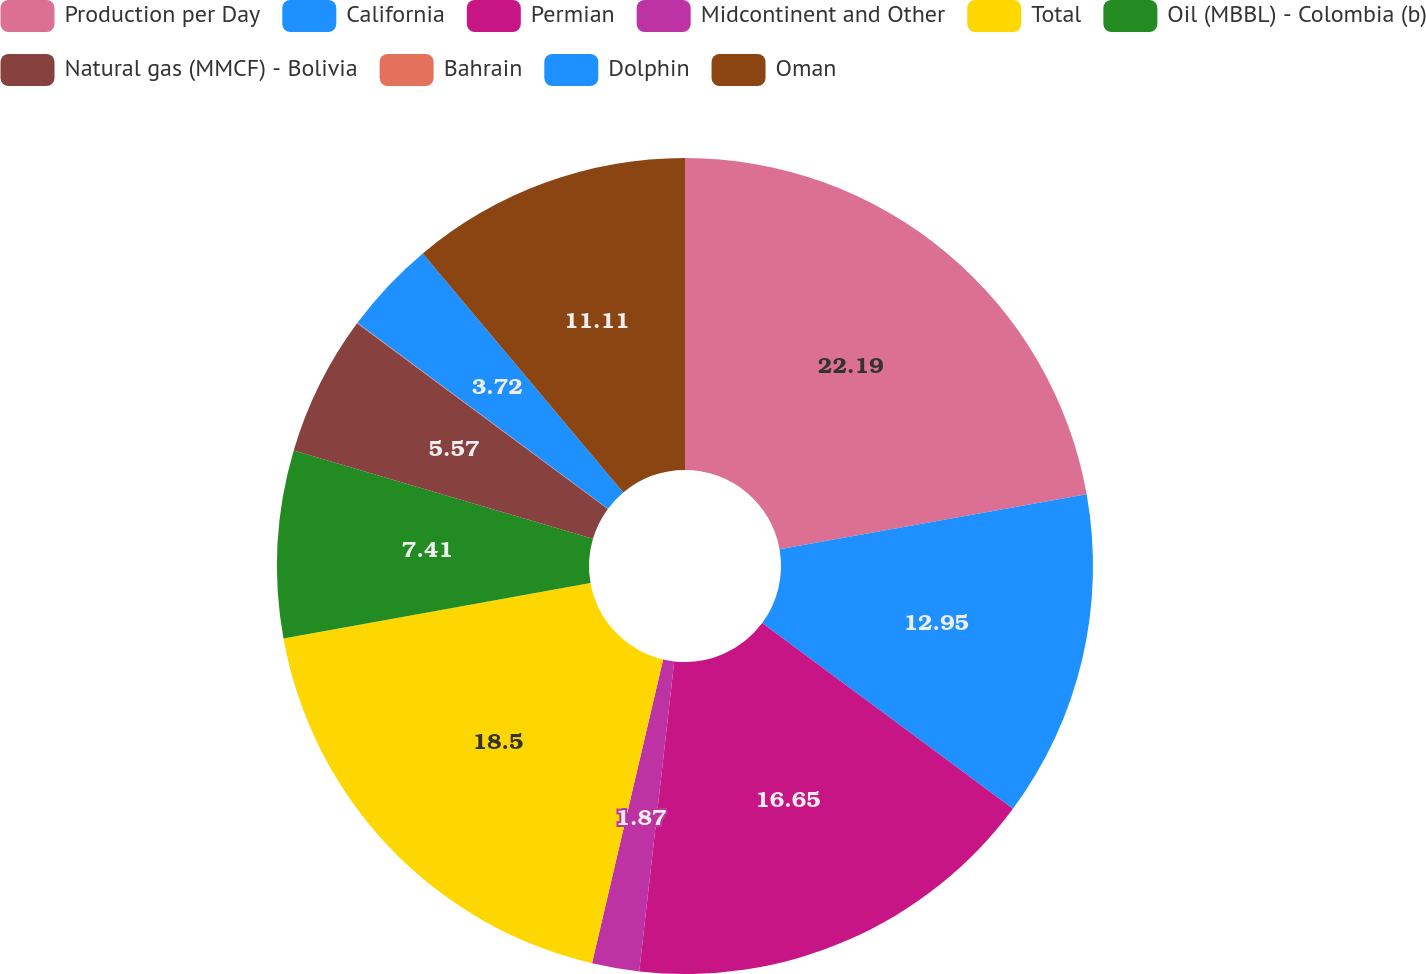Convert chart. <chart><loc_0><loc_0><loc_500><loc_500><pie_chart><fcel>Production per Day<fcel>California<fcel>Permian<fcel>Midcontinent and Other<fcel>Total<fcel>Oil (MBBL) - Colombia (b)<fcel>Natural gas (MMCF) - Bolivia<fcel>Bahrain<fcel>Dolphin<fcel>Oman<nl><fcel>22.19%<fcel>12.95%<fcel>16.65%<fcel>1.87%<fcel>18.5%<fcel>7.41%<fcel>5.57%<fcel>0.03%<fcel>3.72%<fcel>11.11%<nl></chart> 